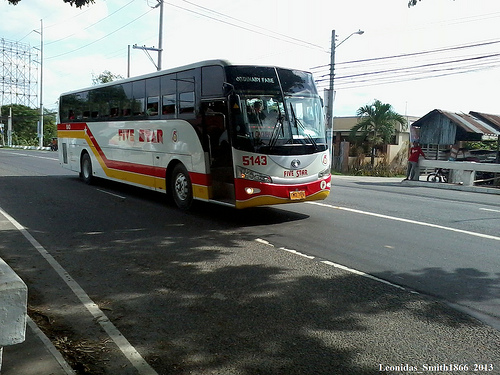What type of area does the photo look like it was taken in? The photo appears to be taken in a suburban area with wide streets, clear skies, and typical roadside greenery that suggests a peaceful, low-traffic environment. 